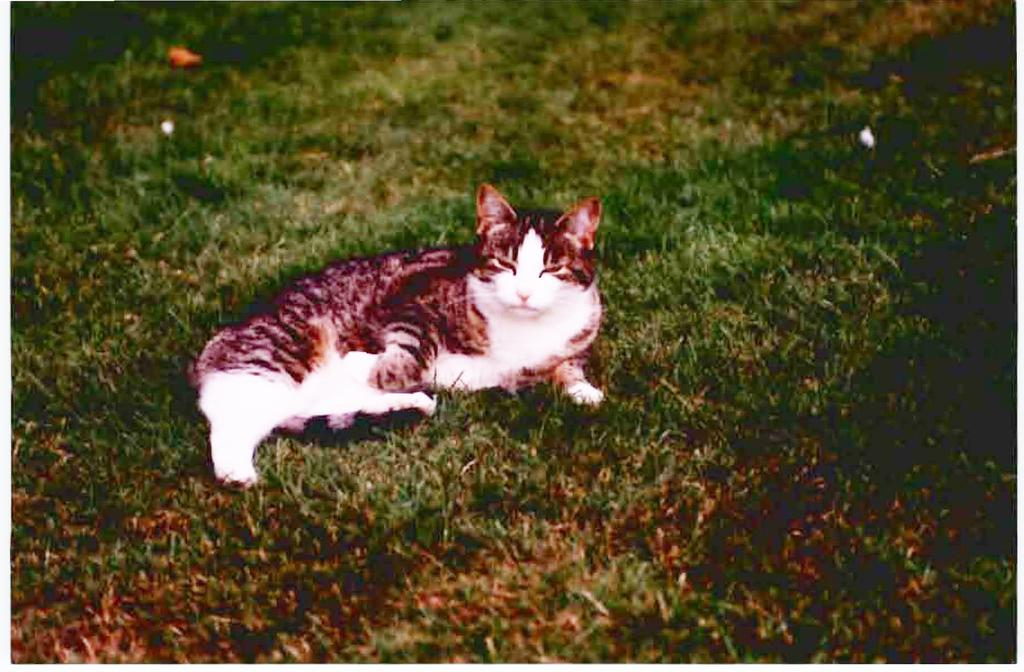What type of animal is in the image? There is a cat in the image. What is the cat doing in the image? The cat is sleeping in the image. Where is the cat located in the image? The cat is on the ground in the image. What type of vegetation is on the ground? There is grass on the ground in the image. How many sisters does the cat have in the image? There is no mention of sisters or any other animals in the image, so it cannot be determined. What position is the chicken in the image? There is no chicken present in the image. 